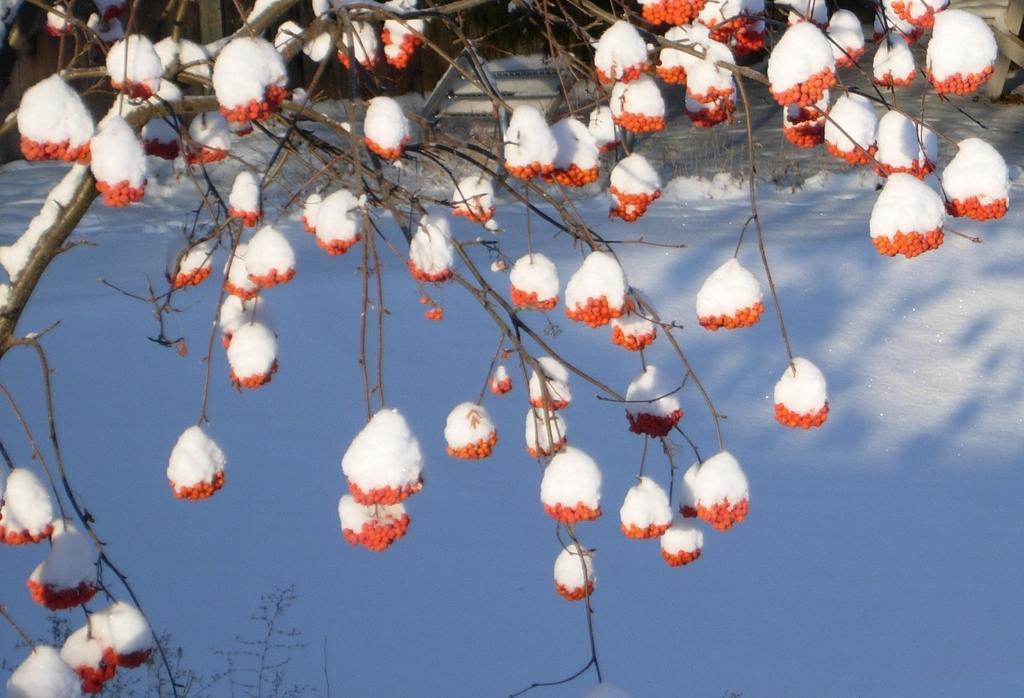Please provide a concise description of this image. In this image I can see a tree and to the tree I can see few orange colored objects and I can see snow on them. I can see some snow on the ground and few other objects in the background. 